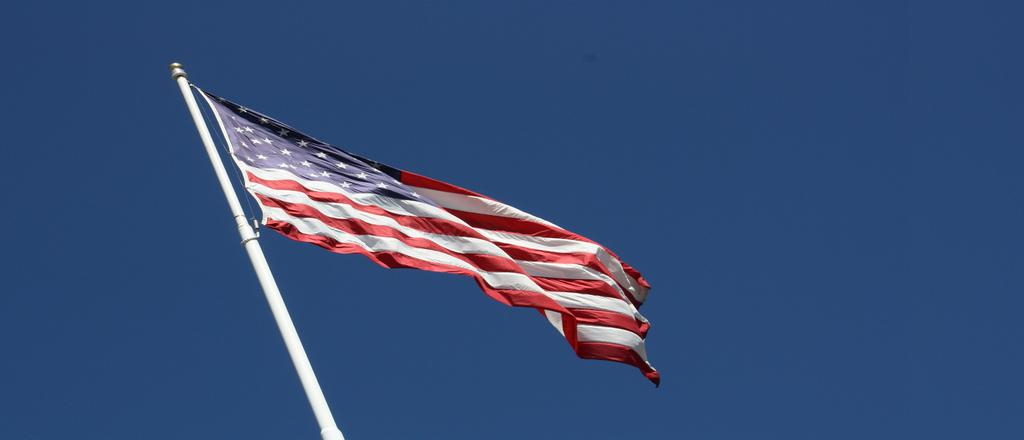What is on the pole that is visible in the image? There is a flag on the pole in the image. What color is the pole in the image? The pole is white in the image. What can be seen in the sky in the image? The sky is blue in the image. How many hands are holding the flag in the image? There are no hands visible in the image; the flag is on the pole. What type of pin is used to attach the flag to the pole? There is no pin mentioned or visible in the image. 